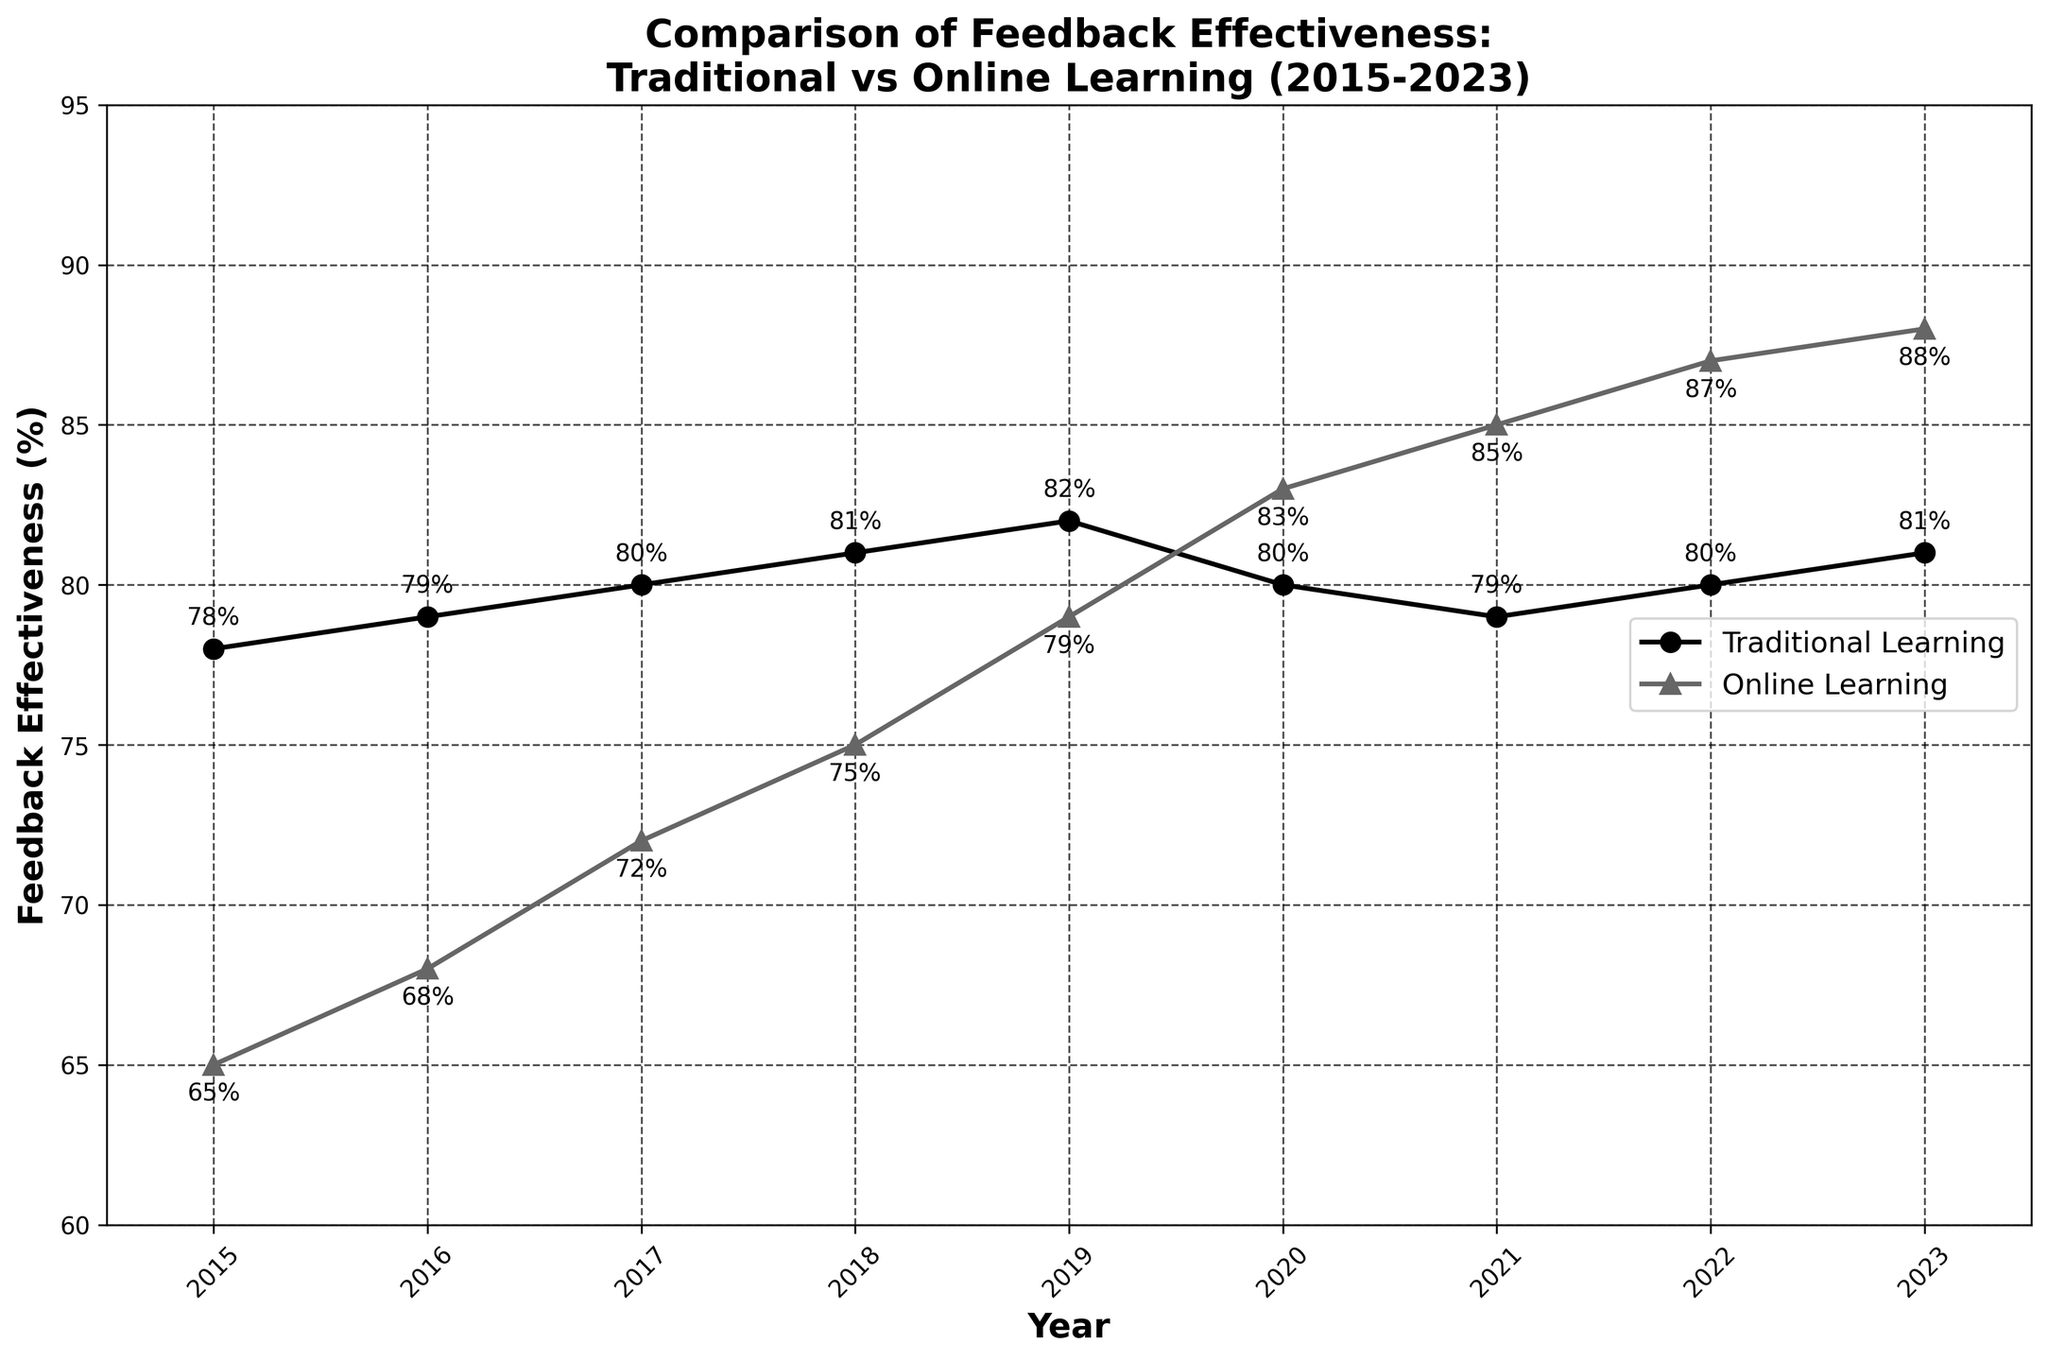What's the highest feedback effectiveness score for traditional learning? To find the highest score for traditional learning, look for the maximum value on the line representing traditional learning feedback effectiveness. The highest point on this line is 82% in 2019.
Answer: 82% What's the trend in feedback effectiveness for online learning from 2015 to 2023? Observe the line representing online learning feedback effectiveness. The overall trend is upward, starting at 65% in 2015 and increasing to 88% in 2023.
Answer: Upward In which year did online learning surpass traditional learning in feedback effectiveness? Look at the intersection points of the two lines. Online learning feedback effectiveness surpasses traditional learning feedback effectiveness in 2020 at 83% versus 80%.
Answer: 2020 Compare the feedback effectiveness of traditional and online learning in 2018. Which one is higher? Find the values for both lines in 2018. Traditional learning is at 81% while online learning is at 75%. Traditional learning is higher.
Answer: Traditional learning What is the difference in feedback effectiveness between traditional and online learning in 2023? Subtract the 2023 value of traditional learning (81%) from that of online learning (88%). The difference is 88% - 81% = 7%.
Answer: 7% What is the average feedback effectiveness for traditional learning from 2015 to 2023? Add all the yearly values for traditional learning and divide by the number of years: (78 + 79 + 80 + 81 + 82 + 80 + 79 + 80 + 81) / 9 = 80.
Answer: 80 During which years is the feedback effectiveness for traditional and online learning equal? Identify the points where the values for both lines are the same. The values never cross or are equal in any given year between 2015 and 2023.
Answer: None Compare the rate of change in feedback effectiveness between 2019 and 2020 for both traditional and online learning. Which one had a greater change? Calculate the differences for each: Traditional learning (80% - 82% = -2%), Online learning (83% - 79% = +4%). Online learning had a greater change.
Answer: Online learning What visual elements make it easy to distinguish between traditional and online learning effectiveness on the graph? The traditional learning line uses circles (o) as markers, while the online learning line uses triangles (^). These markers, combined with different line styles and annotations, help differentiate the two lines.
Answer: Different markers and line styles What's the gap in feedback effectiveness for online learning between 2019 and 2023? Subtract the 2019 value of online learning (79%) from the 2023 value (88%). The gap is 88% - 79% = 9%.
Answer: 9% 